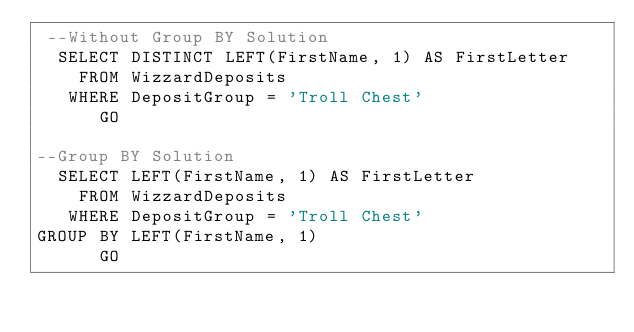<code> <loc_0><loc_0><loc_500><loc_500><_SQL_> --Without Group BY Solution
  SELECT DISTINCT LEFT(FirstName, 1) AS FirstLetter
    FROM WizzardDeposits
   WHERE DepositGroup = 'Troll Chest'
      GO

--Group BY Solution
  SELECT LEFT(FirstName, 1) AS FirstLetter
    FROM WizzardDeposits
   WHERE DepositGroup = 'Troll Chest'
GROUP BY LEFT(FirstName, 1)
      GO</code> 